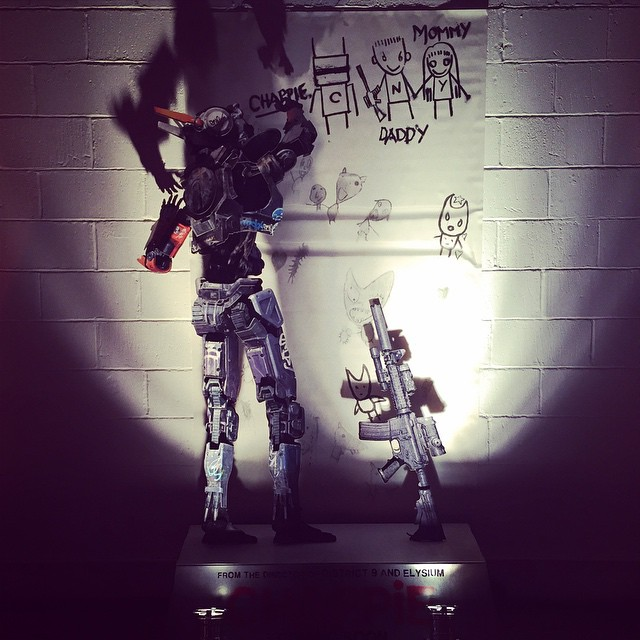How might this image reflect a futuristic vision of family dynamics? This image might reflect a futuristic vision of family dynamics where robots are integral members of the household. In this vision, robots are not just tools but companions that interact emotionally with family members. They engage with children, contributing to their upbringing by offering safety, education, and companionship. This integration blurs the lines between technology and humanity, showcasing a future where the nurturing aspects of family life are enhanced and supported by advanced AI, fostering environments of both technological advancement and emotional richness. 